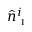Convert formula to latex. <formula><loc_0><loc_0><loc_500><loc_500>\hat { n } _ { i } ^ { i }</formula> 